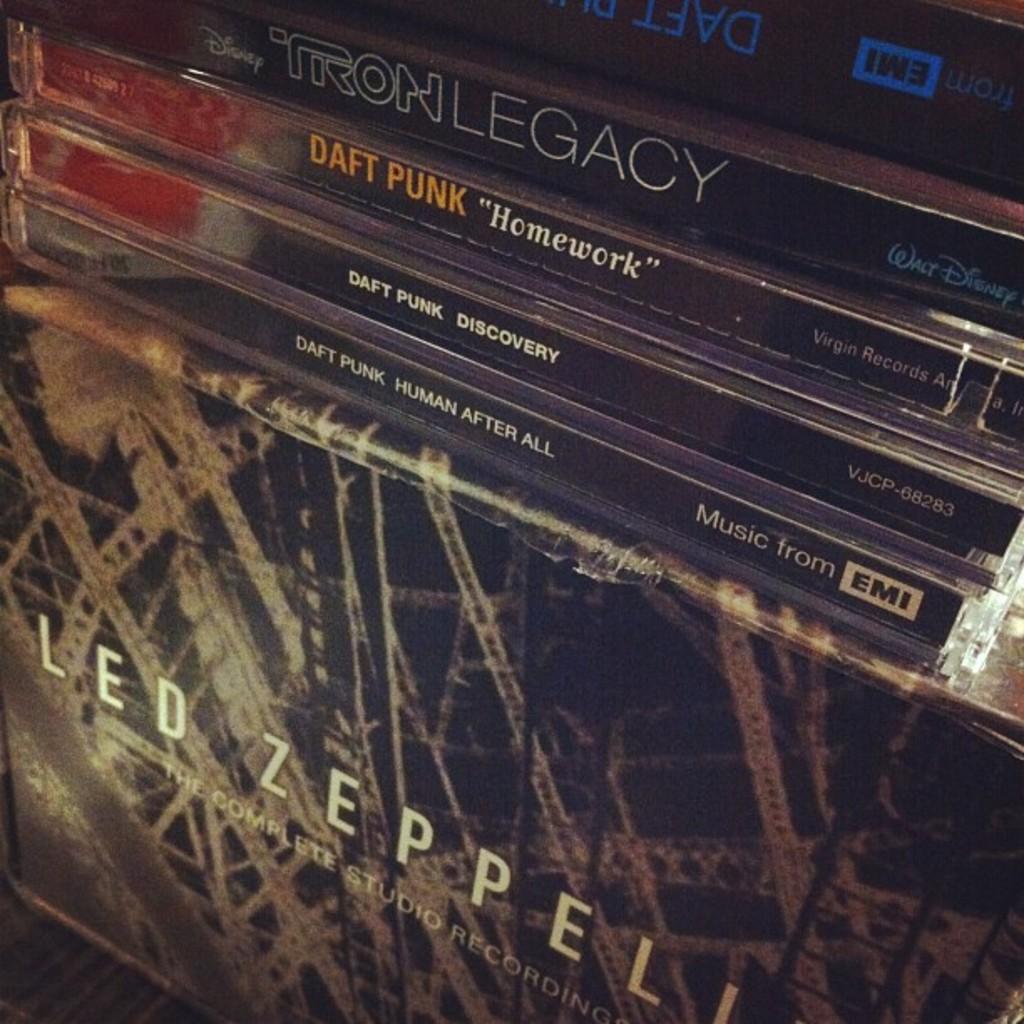Who is the recording artist that made "homework"?
Provide a short and direct response. Daft punk. Which studio published the daft punk human after all album?
Your response must be concise. Emi. 